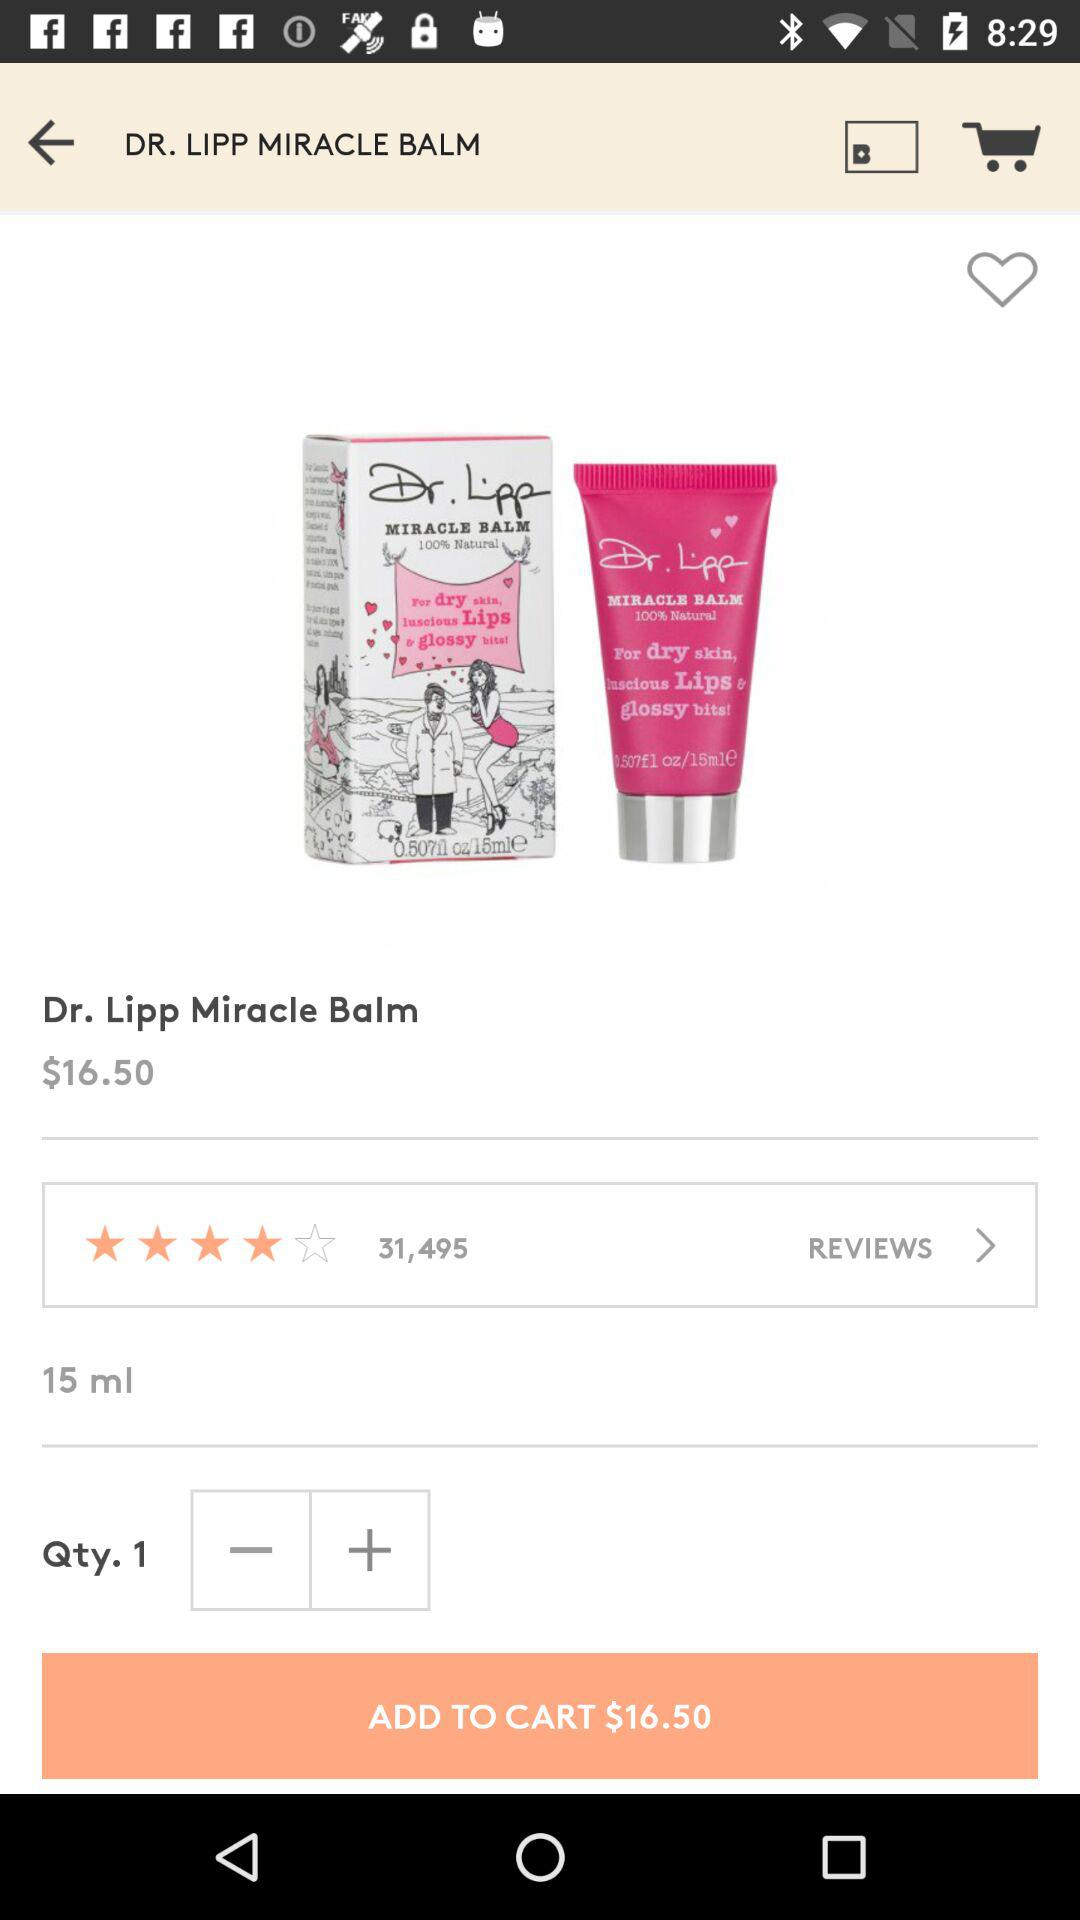What is the total number of reviews on lip balm? The total number of reviews is 31,495. 